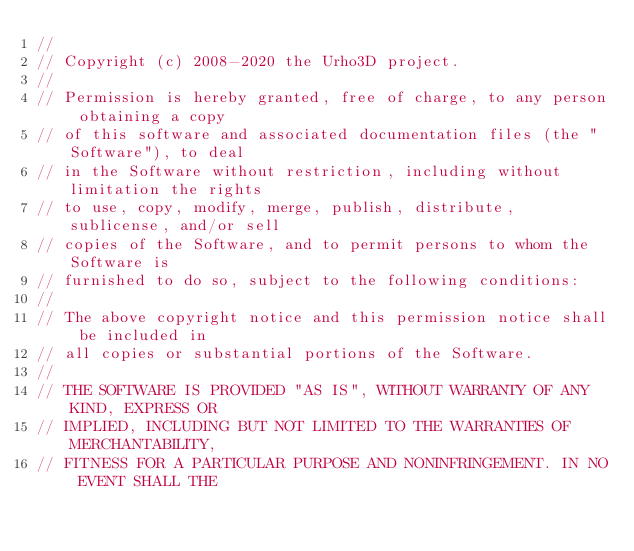<code> <loc_0><loc_0><loc_500><loc_500><_C++_>//
// Copyright (c) 2008-2020 the Urho3D project.
//
// Permission is hereby granted, free of charge, to any person obtaining a copy
// of this software and associated documentation files (the "Software"), to deal
// in the Software without restriction, including without limitation the rights
// to use, copy, modify, merge, publish, distribute, sublicense, and/or sell
// copies of the Software, and to permit persons to whom the Software is
// furnished to do so, subject to the following conditions:
//
// The above copyright notice and this permission notice shall be included in
// all copies or substantial portions of the Software.
//
// THE SOFTWARE IS PROVIDED "AS IS", WITHOUT WARRANTY OF ANY KIND, EXPRESS OR
// IMPLIED, INCLUDING BUT NOT LIMITED TO THE WARRANTIES OF MERCHANTABILITY,
// FITNESS FOR A PARTICULAR PURPOSE AND NONINFRINGEMENT. IN NO EVENT SHALL THE</code> 